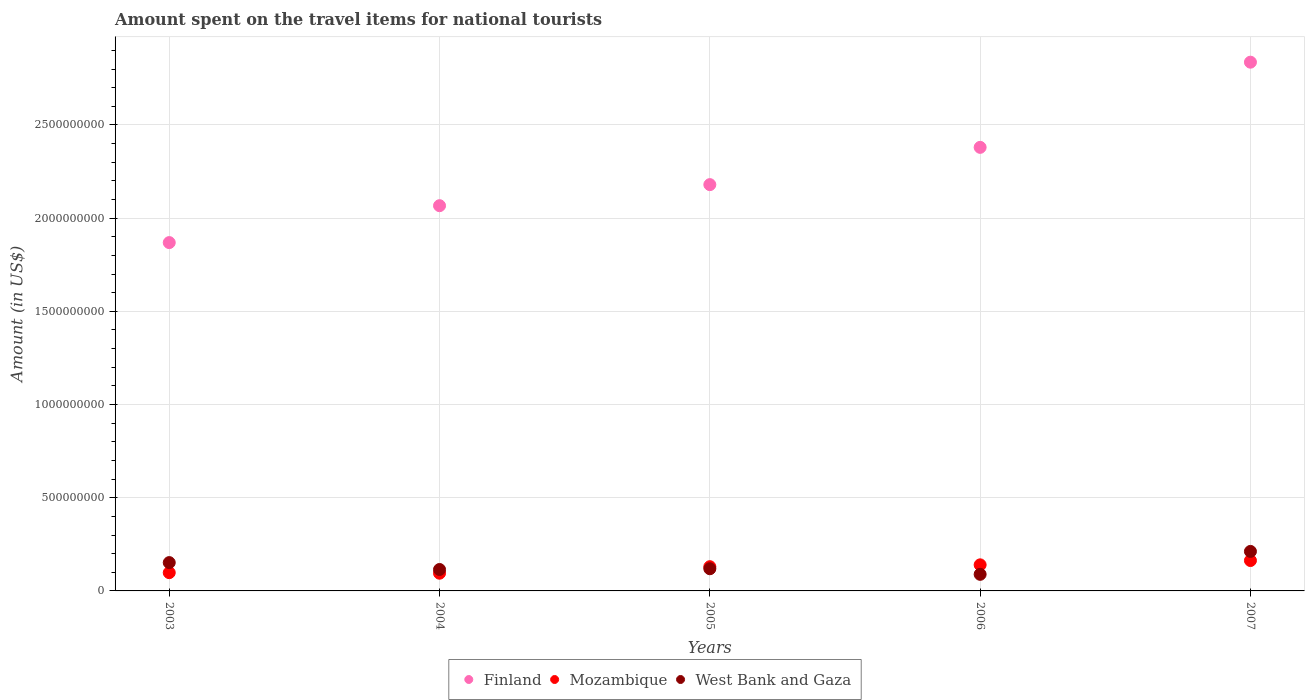Is the number of dotlines equal to the number of legend labels?
Keep it short and to the point. Yes. What is the amount spent on the travel items for national tourists in Mozambique in 2003?
Provide a short and direct response. 9.80e+07. Across all years, what is the maximum amount spent on the travel items for national tourists in West Bank and Gaza?
Ensure brevity in your answer.  2.12e+08. Across all years, what is the minimum amount spent on the travel items for national tourists in Finland?
Provide a short and direct response. 1.87e+09. In which year was the amount spent on the travel items for national tourists in Mozambique maximum?
Keep it short and to the point. 2007. In which year was the amount spent on the travel items for national tourists in Mozambique minimum?
Give a very brief answer. 2004. What is the total amount spent on the travel items for national tourists in West Bank and Gaza in the graph?
Provide a short and direct response. 6.87e+08. What is the difference between the amount spent on the travel items for national tourists in Mozambique in 2006 and that in 2007?
Give a very brief answer. -2.30e+07. What is the difference between the amount spent on the travel items for national tourists in West Bank and Gaza in 2006 and the amount spent on the travel items for national tourists in Finland in 2005?
Make the answer very short. -2.09e+09. What is the average amount spent on the travel items for national tourists in Finland per year?
Provide a succinct answer. 2.27e+09. In the year 2006, what is the difference between the amount spent on the travel items for national tourists in West Bank and Gaza and amount spent on the travel items for national tourists in Finland?
Your answer should be very brief. -2.29e+09. What is the ratio of the amount spent on the travel items for national tourists in West Bank and Gaza in 2005 to that in 2007?
Your answer should be compact. 0.56. Is the difference between the amount spent on the travel items for national tourists in West Bank and Gaza in 2003 and 2005 greater than the difference between the amount spent on the travel items for national tourists in Finland in 2003 and 2005?
Keep it short and to the point. Yes. What is the difference between the highest and the second highest amount spent on the travel items for national tourists in Finland?
Offer a terse response. 4.57e+08. What is the difference between the highest and the lowest amount spent on the travel items for national tourists in West Bank and Gaza?
Your answer should be compact. 1.23e+08. In how many years, is the amount spent on the travel items for national tourists in West Bank and Gaza greater than the average amount spent on the travel items for national tourists in West Bank and Gaza taken over all years?
Provide a succinct answer. 2. Is it the case that in every year, the sum of the amount spent on the travel items for national tourists in Mozambique and amount spent on the travel items for national tourists in West Bank and Gaza  is greater than the amount spent on the travel items for national tourists in Finland?
Offer a very short reply. No. Does the amount spent on the travel items for national tourists in Finland monotonically increase over the years?
Your answer should be compact. Yes. Is the amount spent on the travel items for national tourists in Mozambique strictly greater than the amount spent on the travel items for national tourists in Finland over the years?
Provide a succinct answer. No. How many years are there in the graph?
Provide a short and direct response. 5. What is the difference between two consecutive major ticks on the Y-axis?
Offer a very short reply. 5.00e+08. Does the graph contain any zero values?
Give a very brief answer. No. Where does the legend appear in the graph?
Keep it short and to the point. Bottom center. What is the title of the graph?
Make the answer very short. Amount spent on the travel items for national tourists. What is the Amount (in US$) of Finland in 2003?
Make the answer very short. 1.87e+09. What is the Amount (in US$) of Mozambique in 2003?
Offer a terse response. 9.80e+07. What is the Amount (in US$) of West Bank and Gaza in 2003?
Your answer should be compact. 1.52e+08. What is the Amount (in US$) in Finland in 2004?
Your answer should be compact. 2.07e+09. What is the Amount (in US$) of Mozambique in 2004?
Offer a terse response. 9.50e+07. What is the Amount (in US$) in West Bank and Gaza in 2004?
Keep it short and to the point. 1.15e+08. What is the Amount (in US$) of Finland in 2005?
Provide a short and direct response. 2.18e+09. What is the Amount (in US$) of Mozambique in 2005?
Offer a very short reply. 1.30e+08. What is the Amount (in US$) of West Bank and Gaza in 2005?
Your response must be concise. 1.19e+08. What is the Amount (in US$) of Finland in 2006?
Your answer should be very brief. 2.38e+09. What is the Amount (in US$) in Mozambique in 2006?
Provide a short and direct response. 1.40e+08. What is the Amount (in US$) of West Bank and Gaza in 2006?
Give a very brief answer. 8.90e+07. What is the Amount (in US$) in Finland in 2007?
Ensure brevity in your answer.  2.84e+09. What is the Amount (in US$) in Mozambique in 2007?
Your response must be concise. 1.63e+08. What is the Amount (in US$) in West Bank and Gaza in 2007?
Give a very brief answer. 2.12e+08. Across all years, what is the maximum Amount (in US$) of Finland?
Give a very brief answer. 2.84e+09. Across all years, what is the maximum Amount (in US$) of Mozambique?
Keep it short and to the point. 1.63e+08. Across all years, what is the maximum Amount (in US$) of West Bank and Gaza?
Your response must be concise. 2.12e+08. Across all years, what is the minimum Amount (in US$) in Finland?
Make the answer very short. 1.87e+09. Across all years, what is the minimum Amount (in US$) of Mozambique?
Provide a short and direct response. 9.50e+07. Across all years, what is the minimum Amount (in US$) in West Bank and Gaza?
Offer a very short reply. 8.90e+07. What is the total Amount (in US$) of Finland in the graph?
Offer a very short reply. 1.13e+1. What is the total Amount (in US$) of Mozambique in the graph?
Give a very brief answer. 6.26e+08. What is the total Amount (in US$) of West Bank and Gaza in the graph?
Your answer should be compact. 6.87e+08. What is the difference between the Amount (in US$) of Finland in 2003 and that in 2004?
Give a very brief answer. -1.98e+08. What is the difference between the Amount (in US$) in Mozambique in 2003 and that in 2004?
Your answer should be compact. 3.00e+06. What is the difference between the Amount (in US$) in West Bank and Gaza in 2003 and that in 2004?
Your answer should be compact. 3.70e+07. What is the difference between the Amount (in US$) of Finland in 2003 and that in 2005?
Your response must be concise. -3.11e+08. What is the difference between the Amount (in US$) of Mozambique in 2003 and that in 2005?
Offer a terse response. -3.20e+07. What is the difference between the Amount (in US$) of West Bank and Gaza in 2003 and that in 2005?
Offer a very short reply. 3.30e+07. What is the difference between the Amount (in US$) in Finland in 2003 and that in 2006?
Give a very brief answer. -5.11e+08. What is the difference between the Amount (in US$) of Mozambique in 2003 and that in 2006?
Provide a succinct answer. -4.20e+07. What is the difference between the Amount (in US$) of West Bank and Gaza in 2003 and that in 2006?
Provide a short and direct response. 6.30e+07. What is the difference between the Amount (in US$) of Finland in 2003 and that in 2007?
Make the answer very short. -9.68e+08. What is the difference between the Amount (in US$) in Mozambique in 2003 and that in 2007?
Keep it short and to the point. -6.50e+07. What is the difference between the Amount (in US$) of West Bank and Gaza in 2003 and that in 2007?
Make the answer very short. -6.00e+07. What is the difference between the Amount (in US$) of Finland in 2004 and that in 2005?
Your response must be concise. -1.13e+08. What is the difference between the Amount (in US$) of Mozambique in 2004 and that in 2005?
Make the answer very short. -3.50e+07. What is the difference between the Amount (in US$) of West Bank and Gaza in 2004 and that in 2005?
Provide a succinct answer. -4.00e+06. What is the difference between the Amount (in US$) in Finland in 2004 and that in 2006?
Make the answer very short. -3.13e+08. What is the difference between the Amount (in US$) of Mozambique in 2004 and that in 2006?
Give a very brief answer. -4.50e+07. What is the difference between the Amount (in US$) of West Bank and Gaza in 2004 and that in 2006?
Make the answer very short. 2.60e+07. What is the difference between the Amount (in US$) of Finland in 2004 and that in 2007?
Offer a terse response. -7.70e+08. What is the difference between the Amount (in US$) in Mozambique in 2004 and that in 2007?
Your answer should be very brief. -6.80e+07. What is the difference between the Amount (in US$) in West Bank and Gaza in 2004 and that in 2007?
Offer a terse response. -9.70e+07. What is the difference between the Amount (in US$) of Finland in 2005 and that in 2006?
Give a very brief answer. -2.00e+08. What is the difference between the Amount (in US$) in Mozambique in 2005 and that in 2006?
Keep it short and to the point. -1.00e+07. What is the difference between the Amount (in US$) in West Bank and Gaza in 2005 and that in 2006?
Keep it short and to the point. 3.00e+07. What is the difference between the Amount (in US$) of Finland in 2005 and that in 2007?
Offer a very short reply. -6.57e+08. What is the difference between the Amount (in US$) in Mozambique in 2005 and that in 2007?
Your response must be concise. -3.30e+07. What is the difference between the Amount (in US$) of West Bank and Gaza in 2005 and that in 2007?
Your response must be concise. -9.30e+07. What is the difference between the Amount (in US$) in Finland in 2006 and that in 2007?
Give a very brief answer. -4.57e+08. What is the difference between the Amount (in US$) in Mozambique in 2006 and that in 2007?
Offer a very short reply. -2.30e+07. What is the difference between the Amount (in US$) in West Bank and Gaza in 2006 and that in 2007?
Your response must be concise. -1.23e+08. What is the difference between the Amount (in US$) of Finland in 2003 and the Amount (in US$) of Mozambique in 2004?
Give a very brief answer. 1.77e+09. What is the difference between the Amount (in US$) in Finland in 2003 and the Amount (in US$) in West Bank and Gaza in 2004?
Your response must be concise. 1.75e+09. What is the difference between the Amount (in US$) of Mozambique in 2003 and the Amount (in US$) of West Bank and Gaza in 2004?
Give a very brief answer. -1.70e+07. What is the difference between the Amount (in US$) in Finland in 2003 and the Amount (in US$) in Mozambique in 2005?
Provide a short and direct response. 1.74e+09. What is the difference between the Amount (in US$) of Finland in 2003 and the Amount (in US$) of West Bank and Gaza in 2005?
Offer a terse response. 1.75e+09. What is the difference between the Amount (in US$) in Mozambique in 2003 and the Amount (in US$) in West Bank and Gaza in 2005?
Offer a very short reply. -2.10e+07. What is the difference between the Amount (in US$) of Finland in 2003 and the Amount (in US$) of Mozambique in 2006?
Provide a short and direct response. 1.73e+09. What is the difference between the Amount (in US$) of Finland in 2003 and the Amount (in US$) of West Bank and Gaza in 2006?
Offer a terse response. 1.78e+09. What is the difference between the Amount (in US$) of Mozambique in 2003 and the Amount (in US$) of West Bank and Gaza in 2006?
Keep it short and to the point. 9.00e+06. What is the difference between the Amount (in US$) in Finland in 2003 and the Amount (in US$) in Mozambique in 2007?
Make the answer very short. 1.71e+09. What is the difference between the Amount (in US$) in Finland in 2003 and the Amount (in US$) in West Bank and Gaza in 2007?
Make the answer very short. 1.66e+09. What is the difference between the Amount (in US$) of Mozambique in 2003 and the Amount (in US$) of West Bank and Gaza in 2007?
Provide a short and direct response. -1.14e+08. What is the difference between the Amount (in US$) in Finland in 2004 and the Amount (in US$) in Mozambique in 2005?
Make the answer very short. 1.94e+09. What is the difference between the Amount (in US$) in Finland in 2004 and the Amount (in US$) in West Bank and Gaza in 2005?
Your response must be concise. 1.95e+09. What is the difference between the Amount (in US$) of Mozambique in 2004 and the Amount (in US$) of West Bank and Gaza in 2005?
Give a very brief answer. -2.40e+07. What is the difference between the Amount (in US$) in Finland in 2004 and the Amount (in US$) in Mozambique in 2006?
Your answer should be compact. 1.93e+09. What is the difference between the Amount (in US$) of Finland in 2004 and the Amount (in US$) of West Bank and Gaza in 2006?
Ensure brevity in your answer.  1.98e+09. What is the difference between the Amount (in US$) in Finland in 2004 and the Amount (in US$) in Mozambique in 2007?
Ensure brevity in your answer.  1.90e+09. What is the difference between the Amount (in US$) in Finland in 2004 and the Amount (in US$) in West Bank and Gaza in 2007?
Provide a succinct answer. 1.86e+09. What is the difference between the Amount (in US$) of Mozambique in 2004 and the Amount (in US$) of West Bank and Gaza in 2007?
Keep it short and to the point. -1.17e+08. What is the difference between the Amount (in US$) of Finland in 2005 and the Amount (in US$) of Mozambique in 2006?
Offer a very short reply. 2.04e+09. What is the difference between the Amount (in US$) of Finland in 2005 and the Amount (in US$) of West Bank and Gaza in 2006?
Keep it short and to the point. 2.09e+09. What is the difference between the Amount (in US$) in Mozambique in 2005 and the Amount (in US$) in West Bank and Gaza in 2006?
Provide a short and direct response. 4.10e+07. What is the difference between the Amount (in US$) in Finland in 2005 and the Amount (in US$) in Mozambique in 2007?
Offer a very short reply. 2.02e+09. What is the difference between the Amount (in US$) in Finland in 2005 and the Amount (in US$) in West Bank and Gaza in 2007?
Offer a very short reply. 1.97e+09. What is the difference between the Amount (in US$) in Mozambique in 2005 and the Amount (in US$) in West Bank and Gaza in 2007?
Make the answer very short. -8.20e+07. What is the difference between the Amount (in US$) in Finland in 2006 and the Amount (in US$) in Mozambique in 2007?
Ensure brevity in your answer.  2.22e+09. What is the difference between the Amount (in US$) of Finland in 2006 and the Amount (in US$) of West Bank and Gaza in 2007?
Keep it short and to the point. 2.17e+09. What is the difference between the Amount (in US$) in Mozambique in 2006 and the Amount (in US$) in West Bank and Gaza in 2007?
Offer a terse response. -7.20e+07. What is the average Amount (in US$) of Finland per year?
Make the answer very short. 2.27e+09. What is the average Amount (in US$) in Mozambique per year?
Make the answer very short. 1.25e+08. What is the average Amount (in US$) of West Bank and Gaza per year?
Give a very brief answer. 1.37e+08. In the year 2003, what is the difference between the Amount (in US$) in Finland and Amount (in US$) in Mozambique?
Offer a very short reply. 1.77e+09. In the year 2003, what is the difference between the Amount (in US$) in Finland and Amount (in US$) in West Bank and Gaza?
Give a very brief answer. 1.72e+09. In the year 2003, what is the difference between the Amount (in US$) in Mozambique and Amount (in US$) in West Bank and Gaza?
Keep it short and to the point. -5.40e+07. In the year 2004, what is the difference between the Amount (in US$) of Finland and Amount (in US$) of Mozambique?
Your answer should be very brief. 1.97e+09. In the year 2004, what is the difference between the Amount (in US$) in Finland and Amount (in US$) in West Bank and Gaza?
Provide a succinct answer. 1.95e+09. In the year 2004, what is the difference between the Amount (in US$) of Mozambique and Amount (in US$) of West Bank and Gaza?
Ensure brevity in your answer.  -2.00e+07. In the year 2005, what is the difference between the Amount (in US$) in Finland and Amount (in US$) in Mozambique?
Keep it short and to the point. 2.05e+09. In the year 2005, what is the difference between the Amount (in US$) of Finland and Amount (in US$) of West Bank and Gaza?
Give a very brief answer. 2.06e+09. In the year 2005, what is the difference between the Amount (in US$) of Mozambique and Amount (in US$) of West Bank and Gaza?
Offer a terse response. 1.10e+07. In the year 2006, what is the difference between the Amount (in US$) in Finland and Amount (in US$) in Mozambique?
Keep it short and to the point. 2.24e+09. In the year 2006, what is the difference between the Amount (in US$) in Finland and Amount (in US$) in West Bank and Gaza?
Keep it short and to the point. 2.29e+09. In the year 2006, what is the difference between the Amount (in US$) of Mozambique and Amount (in US$) of West Bank and Gaza?
Your answer should be very brief. 5.10e+07. In the year 2007, what is the difference between the Amount (in US$) of Finland and Amount (in US$) of Mozambique?
Give a very brief answer. 2.67e+09. In the year 2007, what is the difference between the Amount (in US$) of Finland and Amount (in US$) of West Bank and Gaza?
Make the answer very short. 2.62e+09. In the year 2007, what is the difference between the Amount (in US$) of Mozambique and Amount (in US$) of West Bank and Gaza?
Give a very brief answer. -4.90e+07. What is the ratio of the Amount (in US$) in Finland in 2003 to that in 2004?
Your response must be concise. 0.9. What is the ratio of the Amount (in US$) in Mozambique in 2003 to that in 2004?
Give a very brief answer. 1.03. What is the ratio of the Amount (in US$) in West Bank and Gaza in 2003 to that in 2004?
Your response must be concise. 1.32. What is the ratio of the Amount (in US$) in Finland in 2003 to that in 2005?
Provide a succinct answer. 0.86. What is the ratio of the Amount (in US$) in Mozambique in 2003 to that in 2005?
Your answer should be compact. 0.75. What is the ratio of the Amount (in US$) in West Bank and Gaza in 2003 to that in 2005?
Your answer should be compact. 1.28. What is the ratio of the Amount (in US$) in Finland in 2003 to that in 2006?
Offer a terse response. 0.79. What is the ratio of the Amount (in US$) in West Bank and Gaza in 2003 to that in 2006?
Provide a succinct answer. 1.71. What is the ratio of the Amount (in US$) of Finland in 2003 to that in 2007?
Your response must be concise. 0.66. What is the ratio of the Amount (in US$) of Mozambique in 2003 to that in 2007?
Offer a very short reply. 0.6. What is the ratio of the Amount (in US$) of West Bank and Gaza in 2003 to that in 2007?
Your response must be concise. 0.72. What is the ratio of the Amount (in US$) in Finland in 2004 to that in 2005?
Keep it short and to the point. 0.95. What is the ratio of the Amount (in US$) of Mozambique in 2004 to that in 2005?
Your answer should be very brief. 0.73. What is the ratio of the Amount (in US$) of West Bank and Gaza in 2004 to that in 2005?
Make the answer very short. 0.97. What is the ratio of the Amount (in US$) of Finland in 2004 to that in 2006?
Provide a succinct answer. 0.87. What is the ratio of the Amount (in US$) of Mozambique in 2004 to that in 2006?
Provide a succinct answer. 0.68. What is the ratio of the Amount (in US$) in West Bank and Gaza in 2004 to that in 2006?
Provide a succinct answer. 1.29. What is the ratio of the Amount (in US$) in Finland in 2004 to that in 2007?
Give a very brief answer. 0.73. What is the ratio of the Amount (in US$) of Mozambique in 2004 to that in 2007?
Offer a terse response. 0.58. What is the ratio of the Amount (in US$) in West Bank and Gaza in 2004 to that in 2007?
Provide a short and direct response. 0.54. What is the ratio of the Amount (in US$) in Finland in 2005 to that in 2006?
Make the answer very short. 0.92. What is the ratio of the Amount (in US$) in West Bank and Gaza in 2005 to that in 2006?
Offer a very short reply. 1.34. What is the ratio of the Amount (in US$) of Finland in 2005 to that in 2007?
Make the answer very short. 0.77. What is the ratio of the Amount (in US$) of Mozambique in 2005 to that in 2007?
Your answer should be very brief. 0.8. What is the ratio of the Amount (in US$) in West Bank and Gaza in 2005 to that in 2007?
Your answer should be compact. 0.56. What is the ratio of the Amount (in US$) of Finland in 2006 to that in 2007?
Provide a short and direct response. 0.84. What is the ratio of the Amount (in US$) of Mozambique in 2006 to that in 2007?
Offer a terse response. 0.86. What is the ratio of the Amount (in US$) in West Bank and Gaza in 2006 to that in 2007?
Offer a very short reply. 0.42. What is the difference between the highest and the second highest Amount (in US$) of Finland?
Provide a succinct answer. 4.57e+08. What is the difference between the highest and the second highest Amount (in US$) in Mozambique?
Your answer should be very brief. 2.30e+07. What is the difference between the highest and the second highest Amount (in US$) in West Bank and Gaza?
Ensure brevity in your answer.  6.00e+07. What is the difference between the highest and the lowest Amount (in US$) in Finland?
Your answer should be very brief. 9.68e+08. What is the difference between the highest and the lowest Amount (in US$) of Mozambique?
Your response must be concise. 6.80e+07. What is the difference between the highest and the lowest Amount (in US$) of West Bank and Gaza?
Provide a short and direct response. 1.23e+08. 